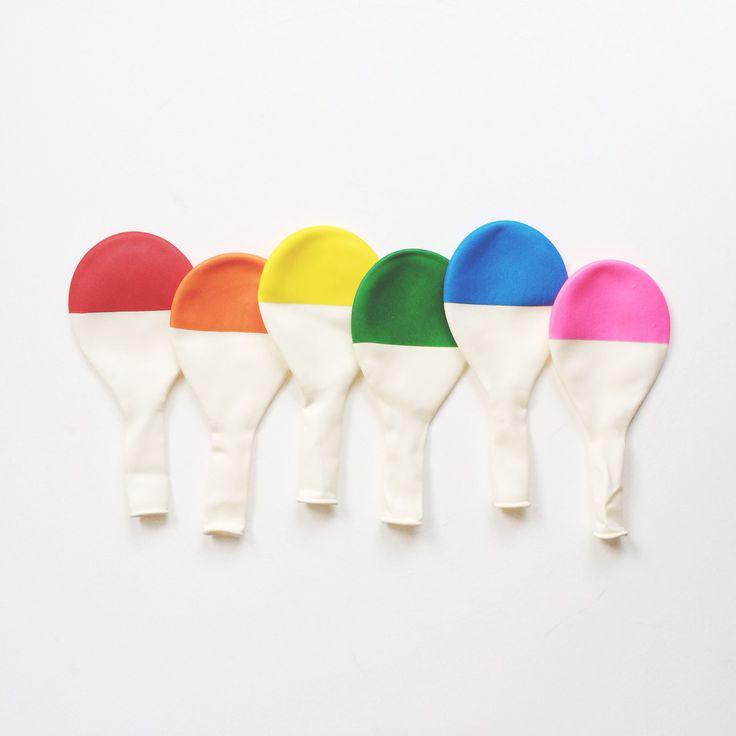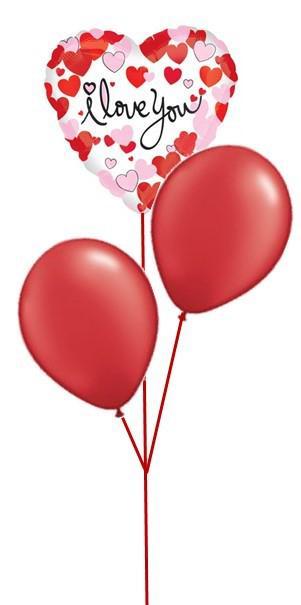The first image is the image on the left, the second image is the image on the right. For the images displayed, is the sentence "At least one balloon is shaped like a number." factually correct? Answer yes or no. No. The first image is the image on the left, the second image is the image on the right. For the images displayed, is the sentence "One image shows a balloon that is in the shape of a number" factually correct? Answer yes or no. No. 